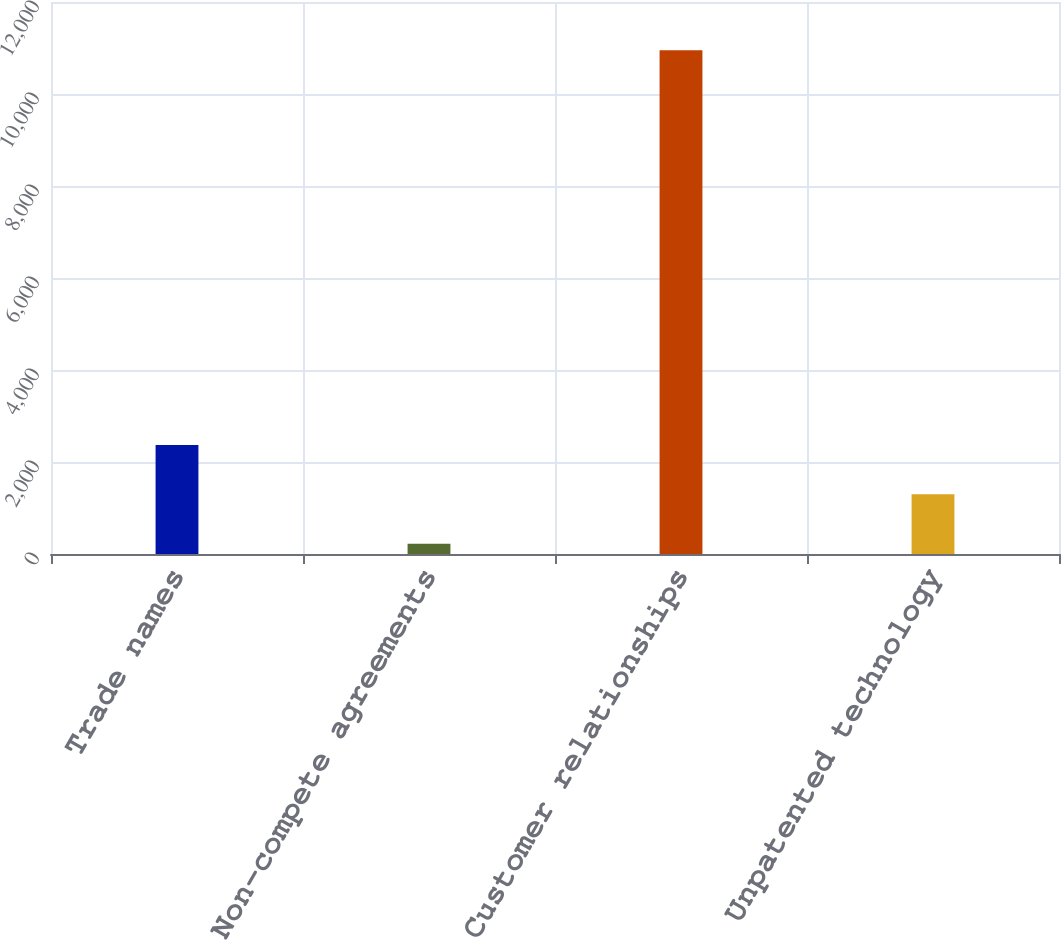Convert chart to OTSL. <chart><loc_0><loc_0><loc_500><loc_500><bar_chart><fcel>Trade names<fcel>Non-compete agreements<fcel>Customer relationships<fcel>Unpatented technology<nl><fcel>2369.2<fcel>224<fcel>10950<fcel>1296.6<nl></chart> 